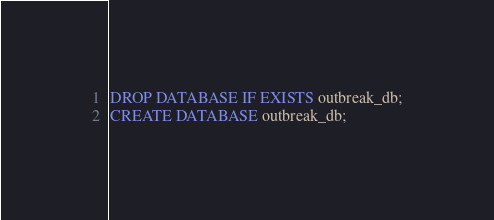Convert code to text. <code><loc_0><loc_0><loc_500><loc_500><_SQL_>DROP DATABASE IF EXISTS outbreak_db;
CREATE DATABASE outbreak_db; 

</code> 